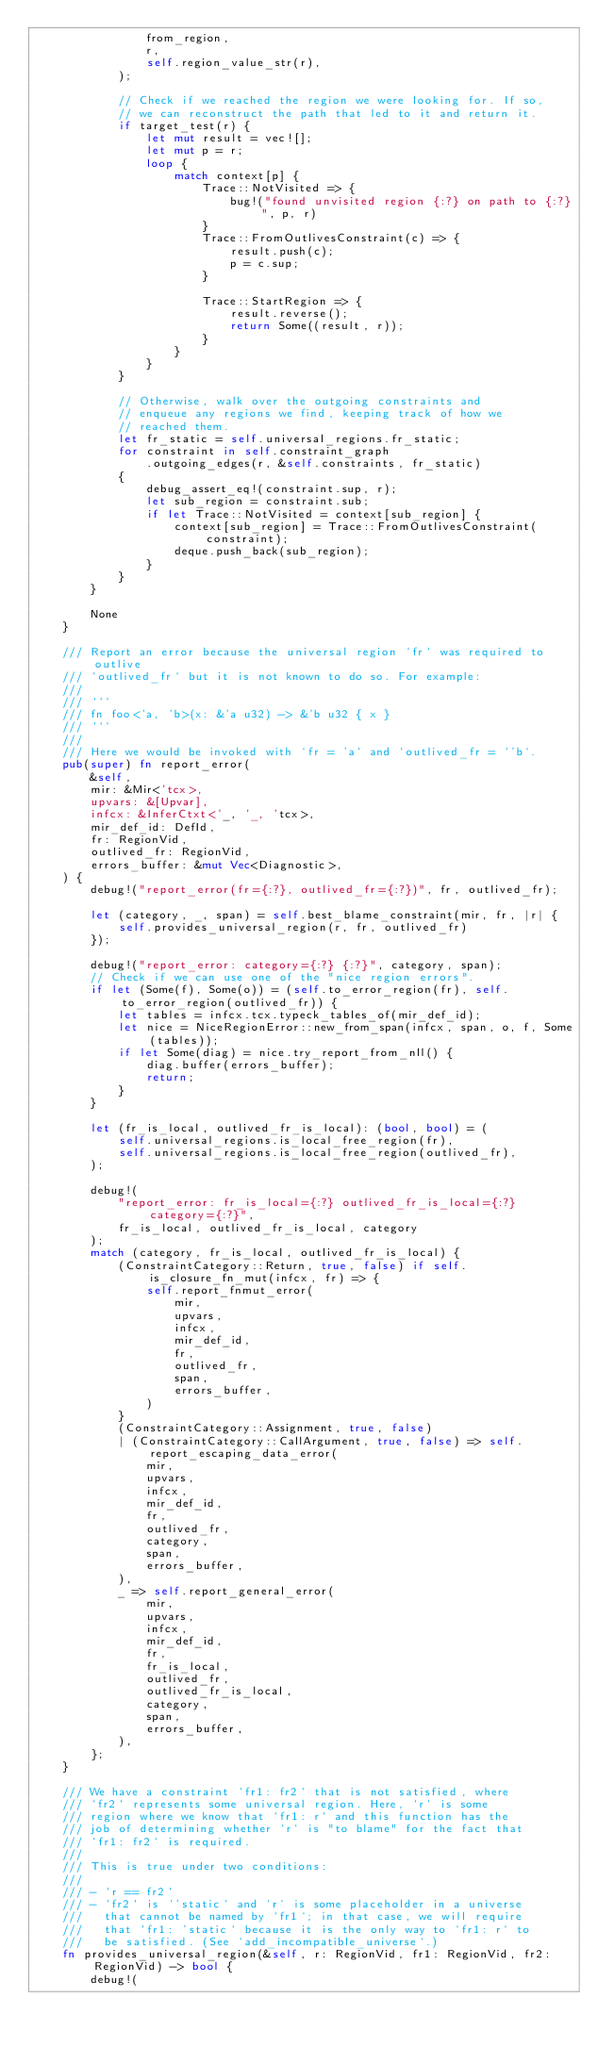<code> <loc_0><loc_0><loc_500><loc_500><_Rust_>                from_region,
                r,
                self.region_value_str(r),
            );

            // Check if we reached the region we were looking for. If so,
            // we can reconstruct the path that led to it and return it.
            if target_test(r) {
                let mut result = vec![];
                let mut p = r;
                loop {
                    match context[p] {
                        Trace::NotVisited => {
                            bug!("found unvisited region {:?} on path to {:?}", p, r)
                        }
                        Trace::FromOutlivesConstraint(c) => {
                            result.push(c);
                            p = c.sup;
                        }

                        Trace::StartRegion => {
                            result.reverse();
                            return Some((result, r));
                        }
                    }
                }
            }

            // Otherwise, walk over the outgoing constraints and
            // enqueue any regions we find, keeping track of how we
            // reached them.
            let fr_static = self.universal_regions.fr_static;
            for constraint in self.constraint_graph
                .outgoing_edges(r, &self.constraints, fr_static)
            {
                debug_assert_eq!(constraint.sup, r);
                let sub_region = constraint.sub;
                if let Trace::NotVisited = context[sub_region] {
                    context[sub_region] = Trace::FromOutlivesConstraint(constraint);
                    deque.push_back(sub_region);
                }
            }
        }

        None
    }

    /// Report an error because the universal region `fr` was required to outlive
    /// `outlived_fr` but it is not known to do so. For example:
    ///
    /// ```
    /// fn foo<'a, 'b>(x: &'a u32) -> &'b u32 { x }
    /// ```
    ///
    /// Here we would be invoked with `fr = 'a` and `outlived_fr = `'b`.
    pub(super) fn report_error(
        &self,
        mir: &Mir<'tcx>,
        upvars: &[Upvar],
        infcx: &InferCtxt<'_, '_, 'tcx>,
        mir_def_id: DefId,
        fr: RegionVid,
        outlived_fr: RegionVid,
        errors_buffer: &mut Vec<Diagnostic>,
    ) {
        debug!("report_error(fr={:?}, outlived_fr={:?})", fr, outlived_fr);

        let (category, _, span) = self.best_blame_constraint(mir, fr, |r| {
            self.provides_universal_region(r, fr, outlived_fr)
        });

        debug!("report_error: category={:?} {:?}", category, span);
        // Check if we can use one of the "nice region errors".
        if let (Some(f), Some(o)) = (self.to_error_region(fr), self.to_error_region(outlived_fr)) {
            let tables = infcx.tcx.typeck_tables_of(mir_def_id);
            let nice = NiceRegionError::new_from_span(infcx, span, o, f, Some(tables));
            if let Some(diag) = nice.try_report_from_nll() {
                diag.buffer(errors_buffer);
                return;
            }
        }

        let (fr_is_local, outlived_fr_is_local): (bool, bool) = (
            self.universal_regions.is_local_free_region(fr),
            self.universal_regions.is_local_free_region(outlived_fr),
        );

        debug!(
            "report_error: fr_is_local={:?} outlived_fr_is_local={:?} category={:?}",
            fr_is_local, outlived_fr_is_local, category
        );
        match (category, fr_is_local, outlived_fr_is_local) {
            (ConstraintCategory::Return, true, false) if self.is_closure_fn_mut(infcx, fr) => {
                self.report_fnmut_error(
                    mir,
                    upvars,
                    infcx,
                    mir_def_id,
                    fr,
                    outlived_fr,
                    span,
                    errors_buffer,
                )
            }
            (ConstraintCategory::Assignment, true, false)
            | (ConstraintCategory::CallArgument, true, false) => self.report_escaping_data_error(
                mir,
                upvars,
                infcx,
                mir_def_id,
                fr,
                outlived_fr,
                category,
                span,
                errors_buffer,
            ),
            _ => self.report_general_error(
                mir,
                upvars,
                infcx,
                mir_def_id,
                fr,
                fr_is_local,
                outlived_fr,
                outlived_fr_is_local,
                category,
                span,
                errors_buffer,
            ),
        };
    }

    /// We have a constraint `fr1: fr2` that is not satisfied, where
    /// `fr2` represents some universal region. Here, `r` is some
    /// region where we know that `fr1: r` and this function has the
    /// job of determining whether `r` is "to blame" for the fact that
    /// `fr1: fr2` is required.
    ///
    /// This is true under two conditions:
    ///
    /// - `r == fr2`
    /// - `fr2` is `'static` and `r` is some placeholder in a universe
    ///   that cannot be named by `fr1`; in that case, we will require
    ///   that `fr1: 'static` because it is the only way to `fr1: r` to
    ///   be satisfied. (See `add_incompatible_universe`.)
    fn provides_universal_region(&self, r: RegionVid, fr1: RegionVid, fr2: RegionVid) -> bool {
        debug!(</code> 